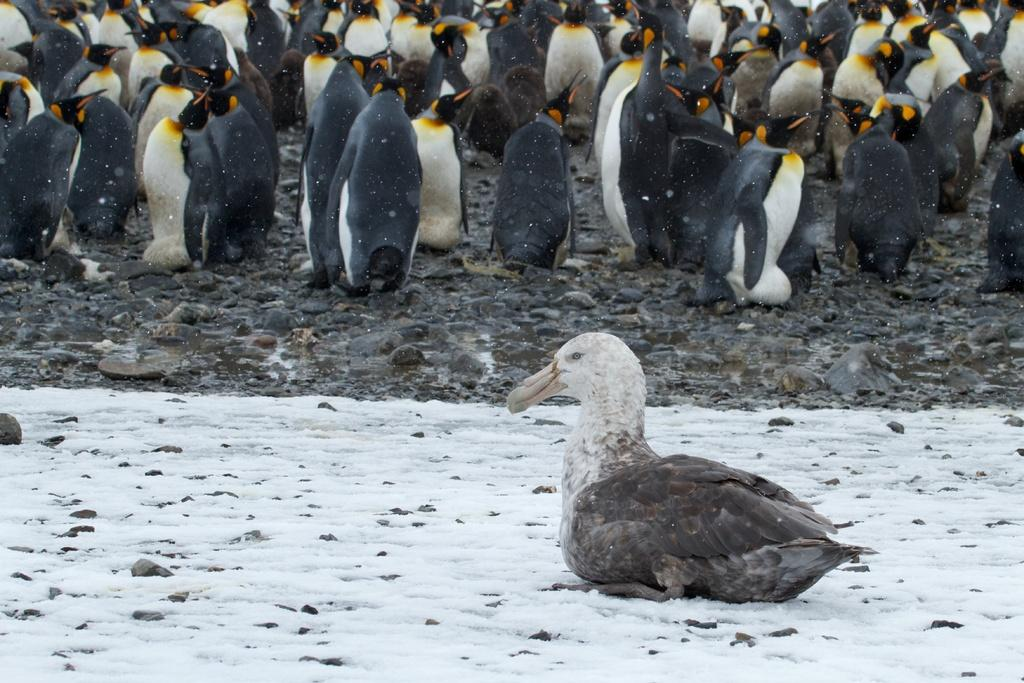What is the main subject of the image? There is a bird sitting on the ground in the image. Can you describe the bird's location? The bird is sitting on the ground. What else can be seen in the background of the image? There are penguins in the background of the image. What type of cheese is the bird holding in its wing in the image? There is no cheese present in the image, and the bird does not have a wing. 